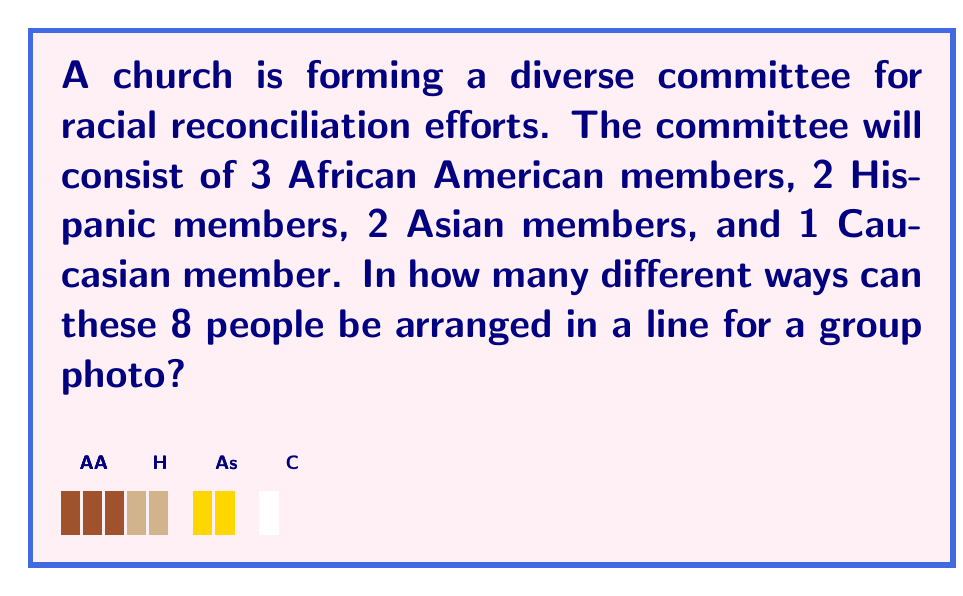Provide a solution to this math problem. To solve this problem, we'll use the multiplication principle of counting and permutations.

1) First, we need to understand that this is a permutation problem. We are arranging all 8 people in a line, where the order matters.

2) If all 8 people were different, we would have 8! arrangements. However, we have groups of identical positions (from the perspective of the arrangement):
   - 3 African American members
   - 2 Hispanic members
   - 2 Asian members
   - 1 Caucasian member

3) When we have identical objects in a permutation, we need to divide by the number of permutations of these identical objects to avoid overcounting.

4) The formula for this scenario is:

   $$ \frac{8!}{3! \cdot 2! \cdot 2! \cdot 1!} $$

5) Let's calculate this step by step:
   $$ \frac{8!}{3! \cdot 2! \cdot 2! \cdot 1!} = \frac{40320}{6 \cdot 2 \cdot 2 \cdot 1} $$
   $$ = \frac{40320}{24} = 1680 $$

Therefore, there are 1680 different ways to arrange these 8 people in a line for a group photo.
Answer: 1680 